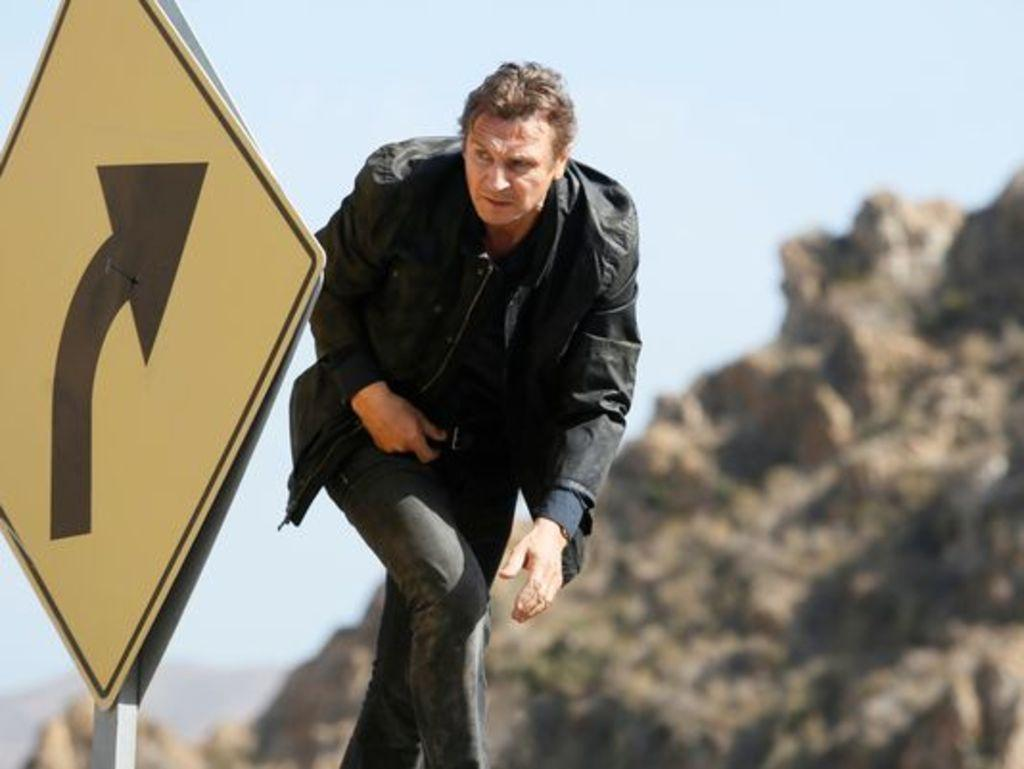Who is present in the image? There is a man in the image. What is the man wearing? The man is wearing a black jacket. What is the man doing in the image? The man is walking. What can be seen on the left side of the man? There is a directional board on the left side of the man. What is visible in the background of the image? There is a hill and the sky visible in the background of the image. How does the man increase the amount of pan in the image? There is no pan present in the image, and the man is not interacting with any pans. 